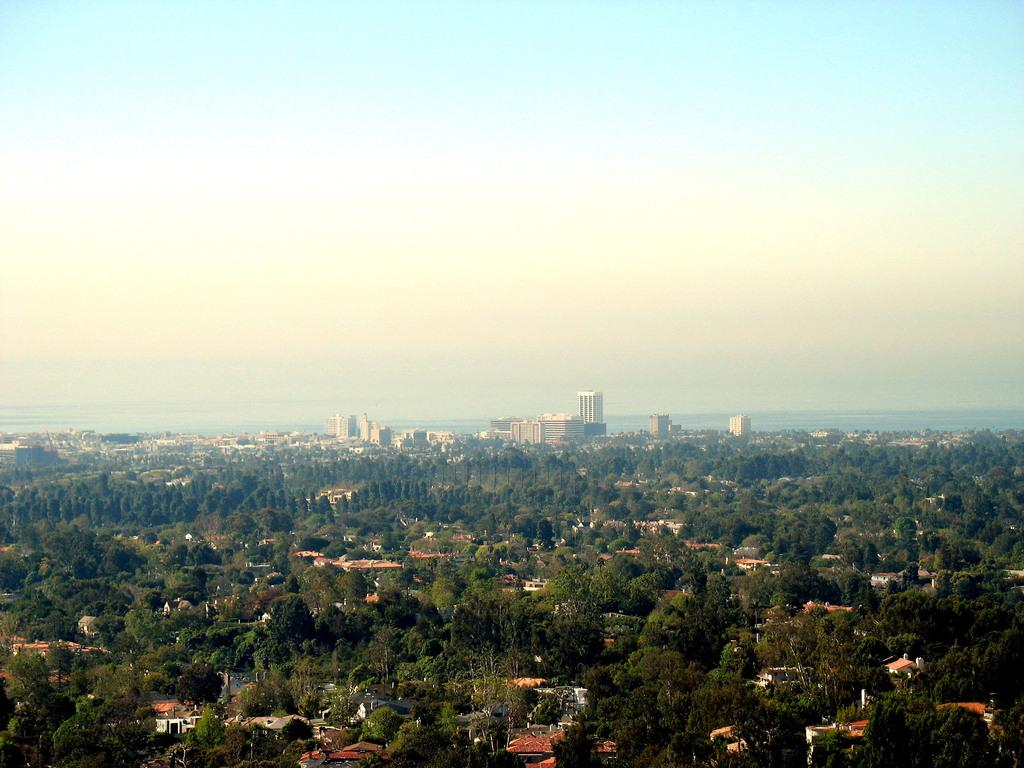What type of structures can be seen in the image? There are buildings in the image. What is the surrounding environment of the buildings? The buildings are located between trees. What is visible at the top of the image? The sky is visible at the top of the image. What type of pest can be seen crawling on the buildings in the image? There are no pests visible on the buildings in the image. What type of string is used to hold the buildings together in the image? The buildings in the image are not held together by any visible string. 